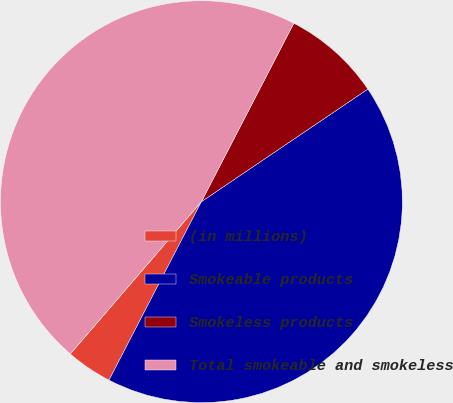Convert chart. <chart><loc_0><loc_0><loc_500><loc_500><pie_chart><fcel>(in millions)<fcel>Smokeable products<fcel>Smokeless products<fcel>Total smokeable and smokeless<nl><fcel>3.71%<fcel>42.07%<fcel>7.93%<fcel>46.29%<nl></chart> 